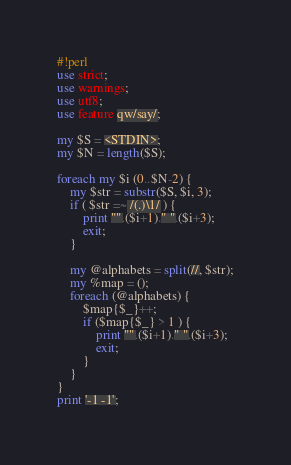<code> <loc_0><loc_0><loc_500><loc_500><_Perl_>#!perl
use strict;
use warnings;
use utf8;
use feature qw/say/;

my $S = <STDIN>;
my $N = length($S);

foreach my $i (0..$N-2) {
    my $str = substr($S, $i, 3);
    if ( $str =~ /(.)\1/ ) {
        print "".($i+1)." ".($i+3);
        exit;
    } 

    my @alphabets = split(//, $str);
    my %map = ();
    foreach (@alphabets) {
        $map{$_}++;
        if ($map{$_} > 1 ) {
            print "".($i+1)." ".($i+3);
            exit;
        }
    }
}
print '-1 -1';</code> 